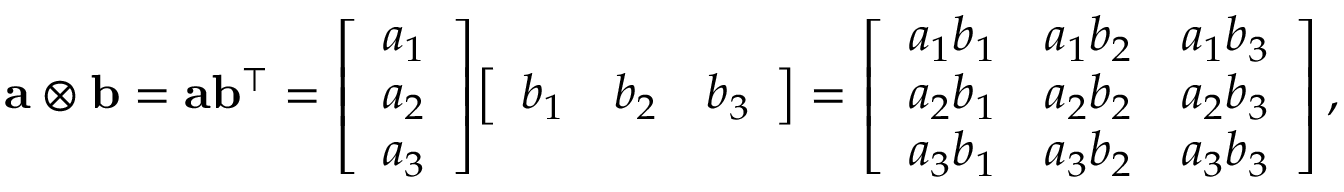Convert formula to latex. <formula><loc_0><loc_0><loc_500><loc_500>a \otimes b = a b ^ { \intercal } = { \left [ \begin{array} { l } { a _ { 1 } } \\ { a _ { 2 } } \\ { a _ { 3 } } \end{array} \right ] } { \left [ \begin{array} { l l l } { b _ { 1 } } & { b _ { 2 } } & { b _ { 3 } } \end{array} \right ] } = { \left [ \begin{array} { l l l } { a _ { 1 } b _ { 1 } } & { a _ { 1 } b _ { 2 } } & { a _ { 1 } b _ { 3 } } \\ { a _ { 2 } b _ { 1 } } & { a _ { 2 } b _ { 2 } } & { a _ { 2 } b _ { 3 } } \\ { a _ { 3 } b _ { 1 } } & { a _ { 3 } b _ { 2 } } & { a _ { 3 } b _ { 3 } } \end{array} \right ] } \, ,</formula> 